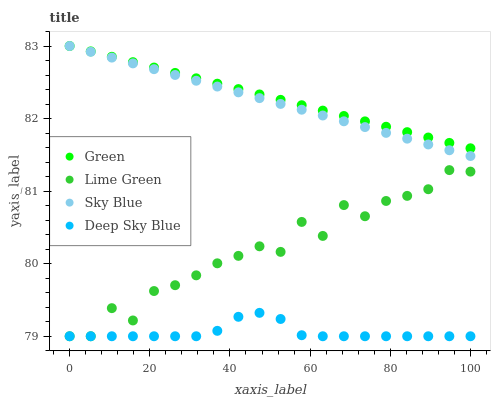Does Deep Sky Blue have the minimum area under the curve?
Answer yes or no. Yes. Does Green have the maximum area under the curve?
Answer yes or no. Yes. Does Green have the minimum area under the curve?
Answer yes or no. No. Does Deep Sky Blue have the maximum area under the curve?
Answer yes or no. No. Is Sky Blue the smoothest?
Answer yes or no. Yes. Is Lime Green the roughest?
Answer yes or no. Yes. Is Green the smoothest?
Answer yes or no. No. Is Green the roughest?
Answer yes or no. No. Does Lime Green have the lowest value?
Answer yes or no. Yes. Does Green have the lowest value?
Answer yes or no. No. Does Sky Blue have the highest value?
Answer yes or no. Yes. Does Deep Sky Blue have the highest value?
Answer yes or no. No. Is Deep Sky Blue less than Green?
Answer yes or no. Yes. Is Green greater than Deep Sky Blue?
Answer yes or no. Yes. Does Lime Green intersect Deep Sky Blue?
Answer yes or no. Yes. Is Lime Green less than Deep Sky Blue?
Answer yes or no. No. Is Lime Green greater than Deep Sky Blue?
Answer yes or no. No. Does Deep Sky Blue intersect Green?
Answer yes or no. No. 